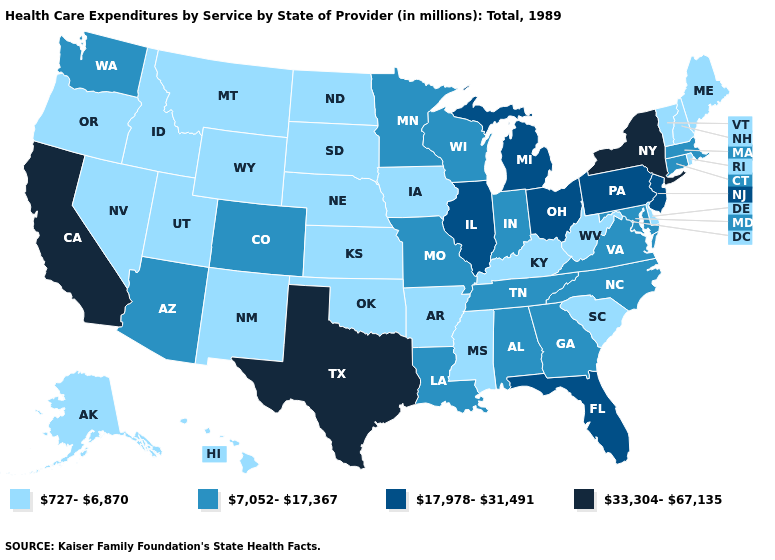Which states have the lowest value in the Northeast?
Concise answer only. Maine, New Hampshire, Rhode Island, Vermont. Name the states that have a value in the range 17,978-31,491?
Short answer required. Florida, Illinois, Michigan, New Jersey, Ohio, Pennsylvania. Name the states that have a value in the range 33,304-67,135?
Keep it brief. California, New York, Texas. What is the value of New Jersey?
Short answer required. 17,978-31,491. Among the states that border Kentucky , which have the highest value?
Be succinct. Illinois, Ohio. Which states have the lowest value in the MidWest?
Give a very brief answer. Iowa, Kansas, Nebraska, North Dakota, South Dakota. Name the states that have a value in the range 727-6,870?
Quick response, please. Alaska, Arkansas, Delaware, Hawaii, Idaho, Iowa, Kansas, Kentucky, Maine, Mississippi, Montana, Nebraska, Nevada, New Hampshire, New Mexico, North Dakota, Oklahoma, Oregon, Rhode Island, South Carolina, South Dakota, Utah, Vermont, West Virginia, Wyoming. What is the value of Nevada?
Answer briefly. 727-6,870. What is the value of Rhode Island?
Concise answer only. 727-6,870. Name the states that have a value in the range 7,052-17,367?
Answer briefly. Alabama, Arizona, Colorado, Connecticut, Georgia, Indiana, Louisiana, Maryland, Massachusetts, Minnesota, Missouri, North Carolina, Tennessee, Virginia, Washington, Wisconsin. Name the states that have a value in the range 727-6,870?
Concise answer only. Alaska, Arkansas, Delaware, Hawaii, Idaho, Iowa, Kansas, Kentucky, Maine, Mississippi, Montana, Nebraska, Nevada, New Hampshire, New Mexico, North Dakota, Oklahoma, Oregon, Rhode Island, South Carolina, South Dakota, Utah, Vermont, West Virginia, Wyoming. Name the states that have a value in the range 7,052-17,367?
Quick response, please. Alabama, Arizona, Colorado, Connecticut, Georgia, Indiana, Louisiana, Maryland, Massachusetts, Minnesota, Missouri, North Carolina, Tennessee, Virginia, Washington, Wisconsin. Among the states that border Arkansas , which have the highest value?
Keep it brief. Texas. Among the states that border Arizona , does Nevada have the lowest value?
Keep it brief. Yes. What is the highest value in states that border Delaware?
Short answer required. 17,978-31,491. 